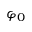<formula> <loc_0><loc_0><loc_500><loc_500>\varphi _ { 0 }</formula> 